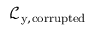<formula> <loc_0><loc_0><loc_500><loc_500>\mathcal { L } _ { y , c o r r u p t e d }</formula> 